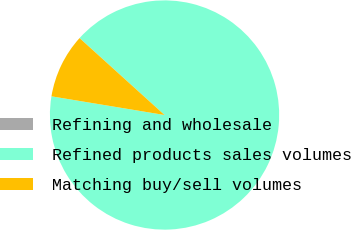Convert chart. <chart><loc_0><loc_0><loc_500><loc_500><pie_chart><fcel>Refining and wholesale<fcel>Refined products sales volumes<fcel>Matching buy/sell volumes<nl><fcel>0.01%<fcel>90.9%<fcel>9.1%<nl></chart> 